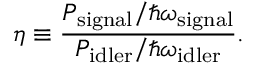<formula> <loc_0><loc_0><loc_500><loc_500>\eta \equiv \frac { P _ { s i g n a l } / \hbar { \omega } _ { s i g n a l } } { P _ { i d l e r } / \hbar { \omega } _ { i d l e r } } .</formula> 